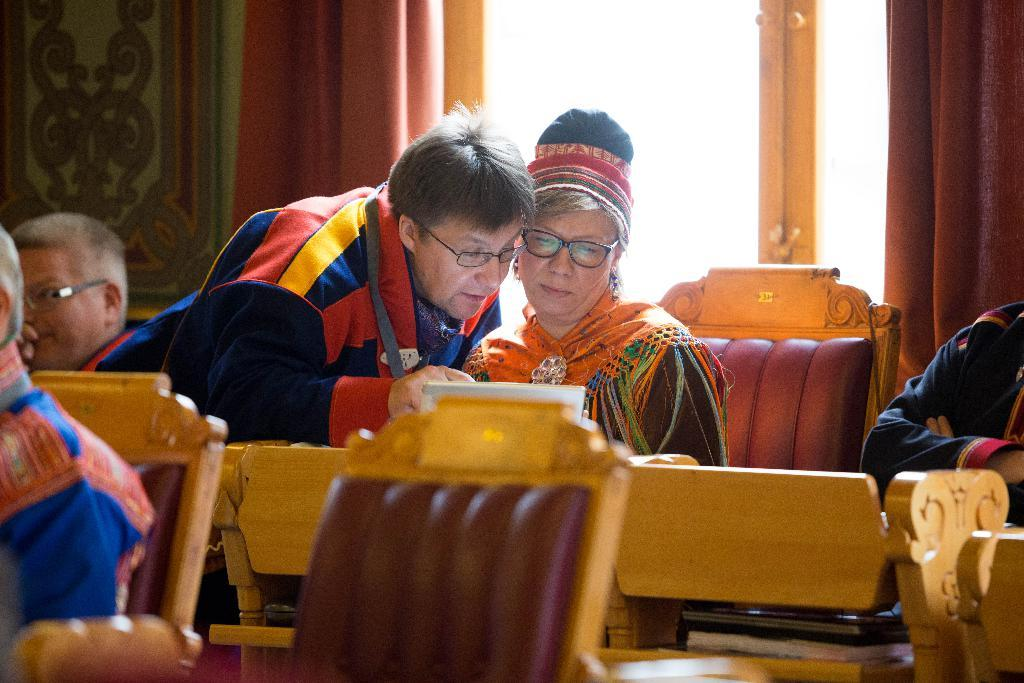What are the people in the image doing? There are people seated on chairs in the image, and two people are talking with each other. What can be seen in the background of the image? There is a glass door and curtains in the image. What type of car can be seen driving through the glass door in the image? There is no car visible in the image, and the glass door is not being driven through. 